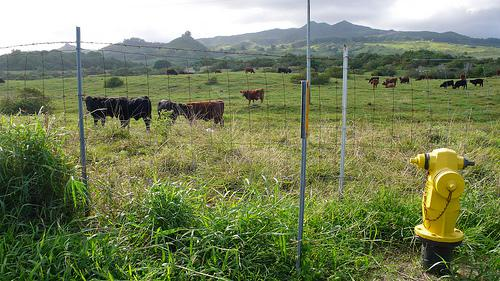Question: what contains the cattle?
Choices:
A. A coral.
B. Barbed wire.
C. The farm.
D. A fence.
Answer with the letter. Answer: D Question: why is a fire hydrant here?
Choices:
A. For water.
B. The housing development.
C. For safety.
D. In case of fire.
Answer with the letter. Answer: D Question: where is the hydrant?
Choices:
A. On the sidewalk.
B. In the grass.
C. By the tree.
D. Outside the fence.
Answer with the letter. Answer: D Question: what color is the hydrant?
Choices:
A. Red.
B. Yellow.
C. White.
D. Green.
Answer with the letter. Answer: B 